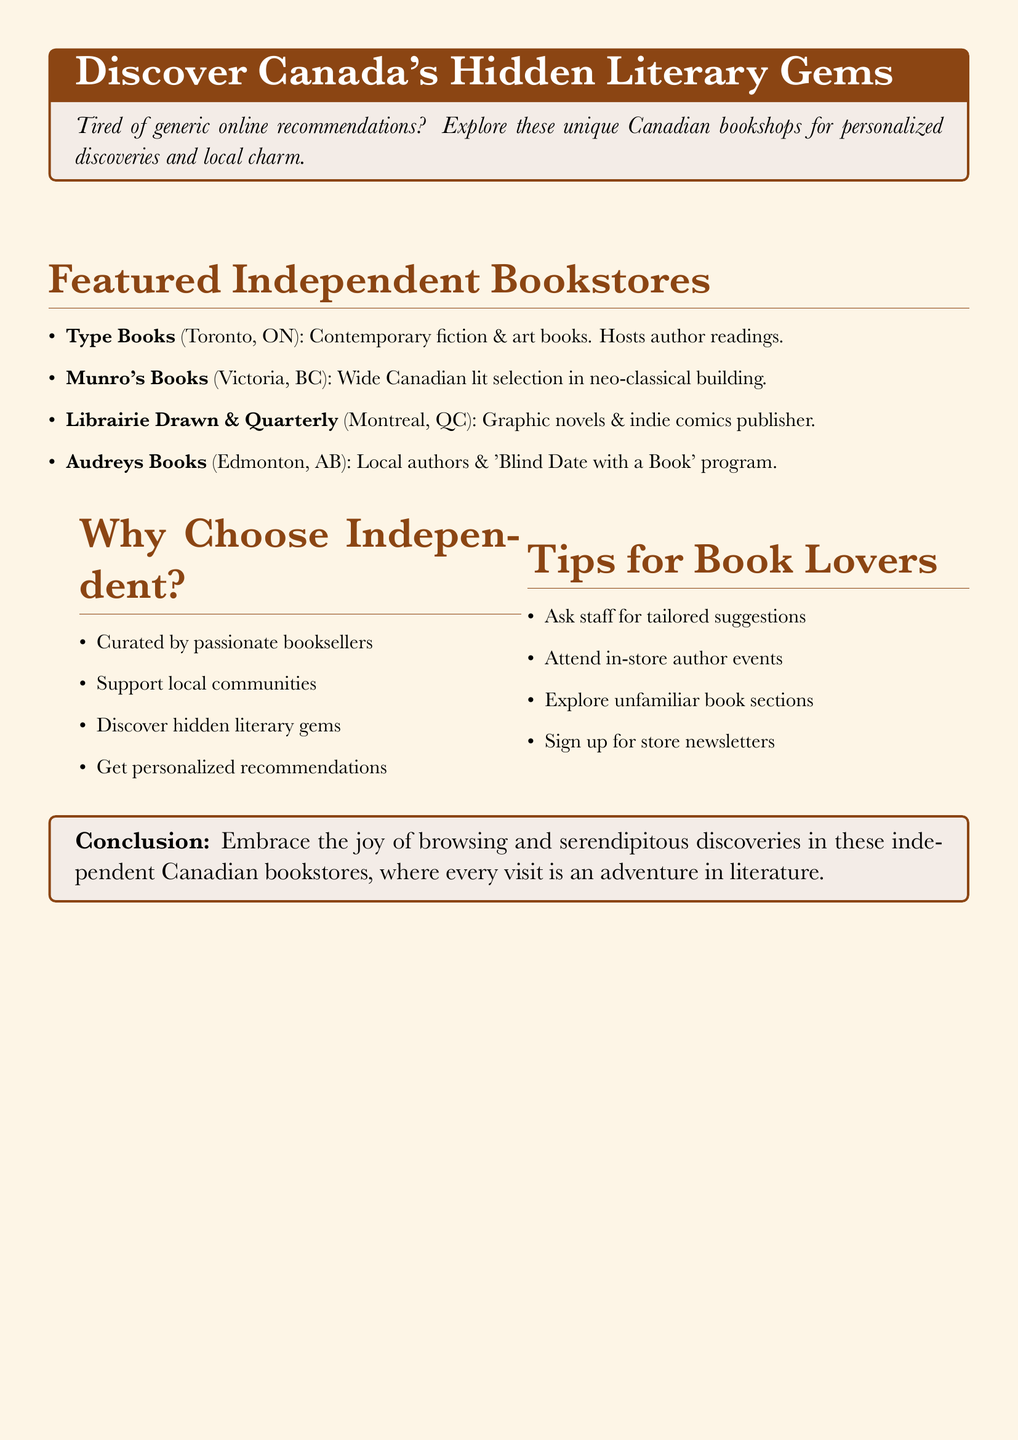What is the name of the bookstore in Toronto? The document lists Type Books as the bookstore in Toronto.
Answer: Type Books What unique feature does Munro's Books have? The document states that Munro's Books is located in a neo-classical building.
Answer: Neo-classical building Which bookstore specializes in graphic novels? The text indicates that Librairie Drawn & Quarterly specializes in graphic novels and indie comics.
Answer: Librairie Drawn & Quarterly How many featured independent bookstores are mentioned? The number of bookstores listed in the featured independent section is four.
Answer: Four What program is offered by Audreys Books? Audreys Books offers a 'Blind Date with a Book' program as stated in the document.
Answer: 'Blind Date with a Book' Why is choosing independent bookstores encouraged? One reason is that they are curated by passionate booksellers, highlighted in the why choose independent section.
Answer: Curated by passionate booksellers What is one tip for book lovers mentioned? The document suggests asking staff for tailored suggestions as a tip for book lovers.
Answer: Ask staff for tailored suggestions What type of literature can you find at Type Books? The document mentions that Type Books features contemporary fiction and art books.
Answer: Contemporary fiction & art books 